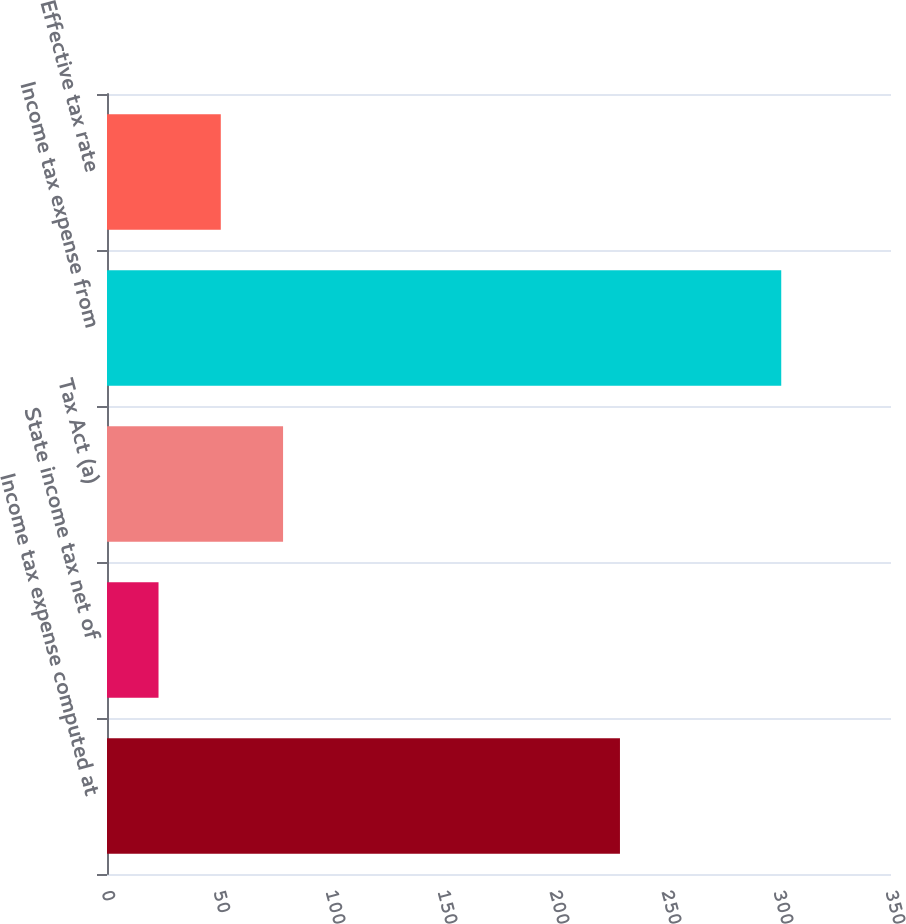<chart> <loc_0><loc_0><loc_500><loc_500><bar_chart><fcel>Income tax expense computed at<fcel>State income tax net of<fcel>Tax Act (a)<fcel>Income tax expense from<fcel>Effective tax rate<nl><fcel>229<fcel>23<fcel>78.6<fcel>301<fcel>50.8<nl></chart> 